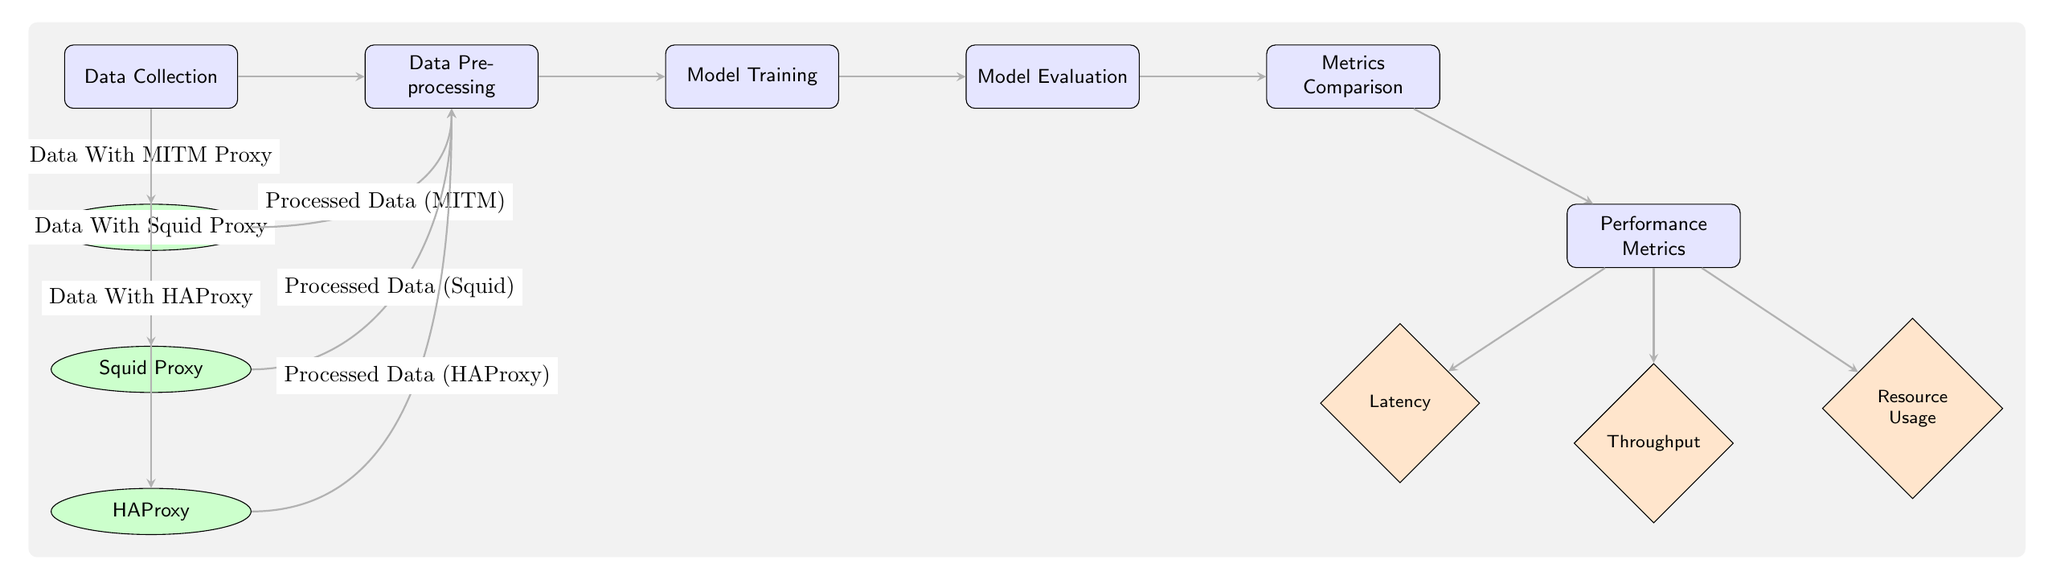What is the first step in the workflow? The first step in the workflow is labeled as "Data Collection". It is positioned in the far left of the diagram, serving as the starting point for the entire process.
Answer: Data Collection How many proxies are represented in the diagram? The diagram features three proxies, which are listed below the "Data Collection" node and represented by ellipses. They are MITM Proxy, Squid Proxy, and HAProxy.
Answer: 3 What is the output of the evaluation node? The output of the evaluation node leads directly to the comparison of metrics, marking it as a necessary step before performance evaluation. The diagram shows an arrow from the "Model Evaluation" node to the "Metrics Comparison" node.
Answer: Metrics Comparison What performance metric is associated with resource usage? Resource usage is explicitly represented as a diamond-shaped node, positioned below a box labeled "Performance Metrics", indicating that it is one of the metrics used for comparison.
Answer: Resource Usage Which proxy's processed data enters the preprocessing step directly from its data? The processed data from the MITM proxy is shown to enter the "Data Preprocessing" step first, along with processed data from Squid and HAProxy, following their respective connections from the data collected.
Answer: MITM Proxy What is the connection type between the "Model Evaluation" and "Metrics Comparison" nodes? The connection type is an arrow, which indicates the direction of the workflow and the sequence of steps from evaluation to comparison. This highlights the flow of information within the diagram.
Answer: Arrow Which proxy is placed at the highest position in the proxy section? The proxy at the highest position is the MITM Proxy, as the other proxies (Squid and HAProxy) are located below it in the diagram layout.
Answer: MITM Proxy What flow happens after the data preprocessing step? After the data preprocessing step, the next step in the workflow is "Model Training", which is indicated by a directed arrow moving rightward from the "Data Preprocessing" node.
Answer: Model Training What is the shape of the node that represents throughput? The node representing throughput is a diamond shape, indicating that it is one of the performance metrics considered in the metrics comparison stage of the workflow.
Answer: Diamond 